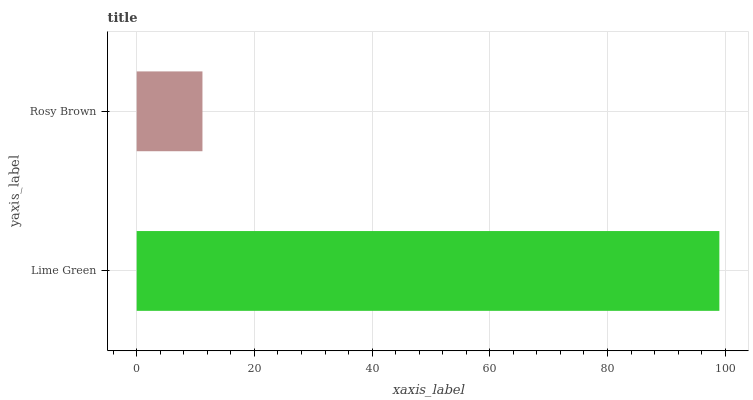Is Rosy Brown the minimum?
Answer yes or no. Yes. Is Lime Green the maximum?
Answer yes or no. Yes. Is Rosy Brown the maximum?
Answer yes or no. No. Is Lime Green greater than Rosy Brown?
Answer yes or no. Yes. Is Rosy Brown less than Lime Green?
Answer yes or no. Yes. Is Rosy Brown greater than Lime Green?
Answer yes or no. No. Is Lime Green less than Rosy Brown?
Answer yes or no. No. Is Lime Green the high median?
Answer yes or no. Yes. Is Rosy Brown the low median?
Answer yes or no. Yes. Is Rosy Brown the high median?
Answer yes or no. No. Is Lime Green the low median?
Answer yes or no. No. 